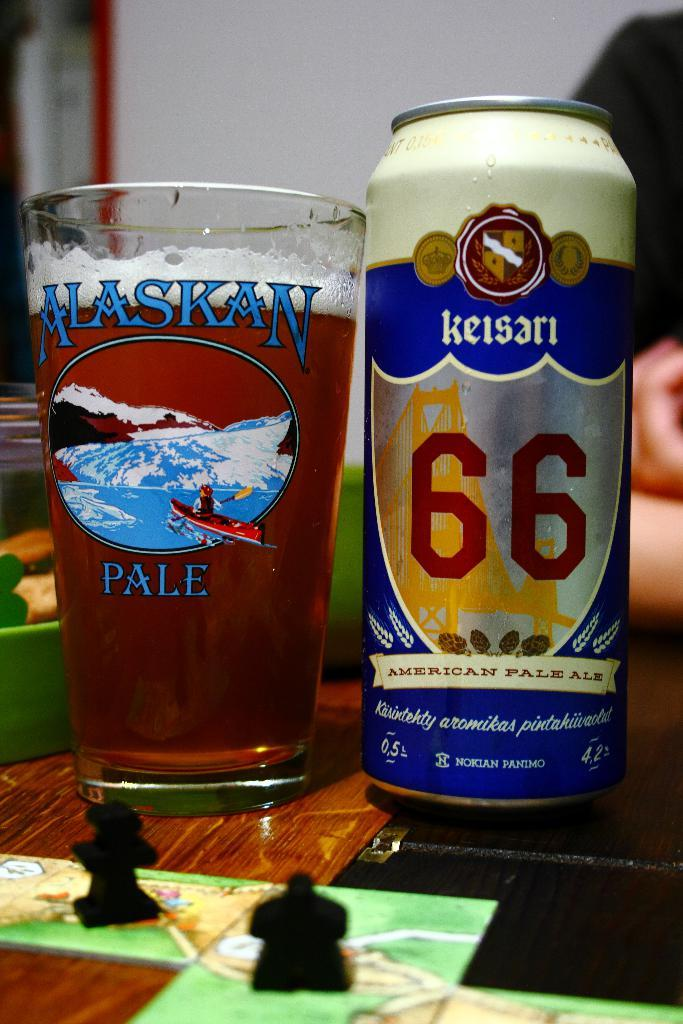<image>
Present a compact description of the photo's key features. A can of Keisari beer is in an Alaskan pale glass. 